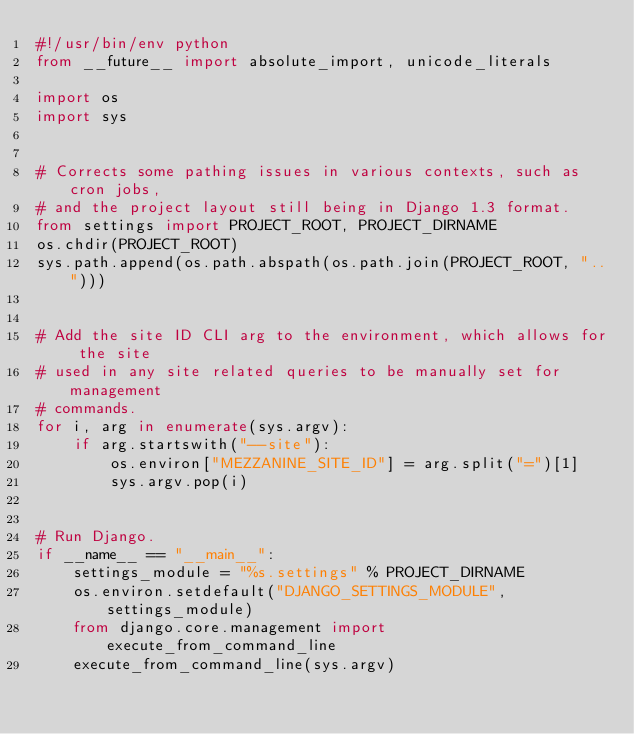Convert code to text. <code><loc_0><loc_0><loc_500><loc_500><_Python_>#!/usr/bin/env python
from __future__ import absolute_import, unicode_literals

import os
import sys


# Corrects some pathing issues in various contexts, such as cron jobs,
# and the project layout still being in Django 1.3 format.
from settings import PROJECT_ROOT, PROJECT_DIRNAME
os.chdir(PROJECT_ROOT)
sys.path.append(os.path.abspath(os.path.join(PROJECT_ROOT, "..")))


# Add the site ID CLI arg to the environment, which allows for the site
# used in any site related queries to be manually set for management
# commands.
for i, arg in enumerate(sys.argv):
    if arg.startswith("--site"):
        os.environ["MEZZANINE_SITE_ID"] = arg.split("=")[1]
        sys.argv.pop(i)


# Run Django.
if __name__ == "__main__":
    settings_module = "%s.settings" % PROJECT_DIRNAME
    os.environ.setdefault("DJANGO_SETTINGS_MODULE", settings_module)
    from django.core.management import execute_from_command_line
    execute_from_command_line(sys.argv)
</code> 